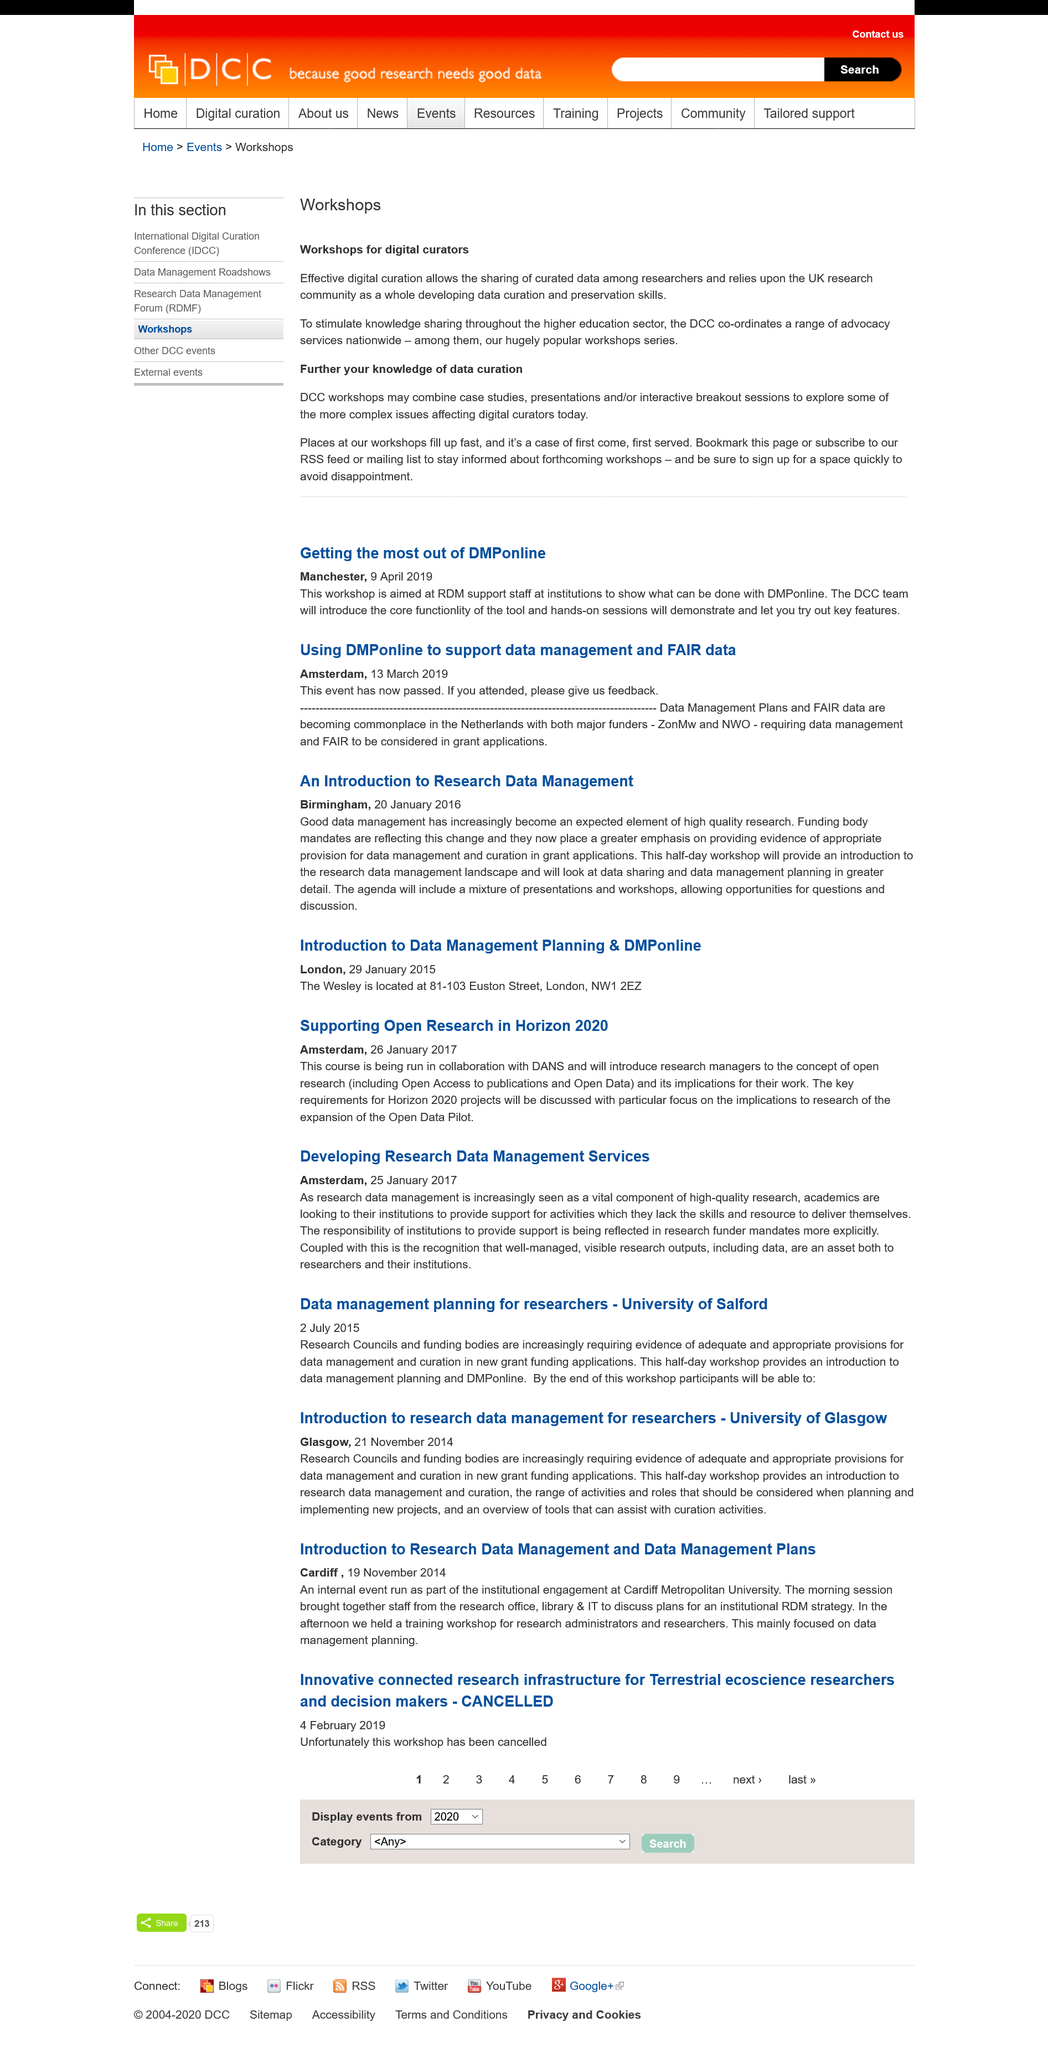Outline some significant characteristics in this image. DMPonline, a tool presented during the workshop, is a powerful tool for developing and maintaining data management plans. Effective digital curation is what allows researchers to share curated data among themselves. An Introduction to Research Data Management was published in Birmingham. It has been reported that attendants are now being asked to provide feedback regarding their experiences at the company. The "Has the "Innovative connected research infrastructure for Terrestrial ecoscience researchers and decision makers" workshop been cancelled? Yes, it has been cancelled..." workshop has been cancelled. 